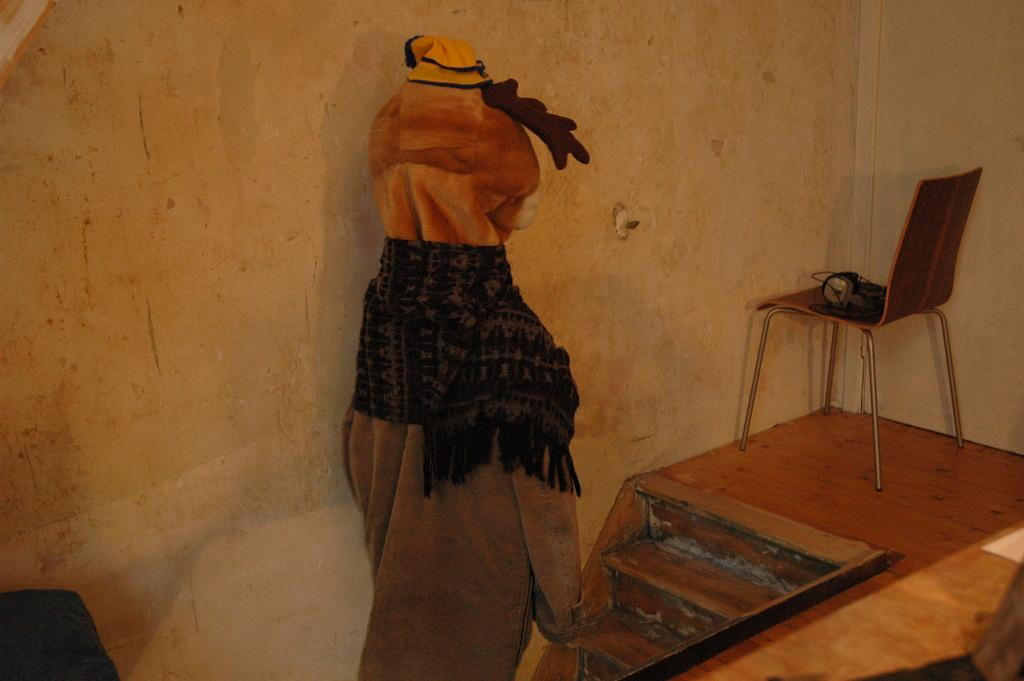What is hanging on the wall in the image? There is a dress hanging on the wall in the image. What can be seen near the dress on the wall? There are wooden stairs beside the dress. What piece of furniture is present in the image with headphones on it? There is a chair with headphones on it in the image. What type of sand can be seen on the chair with headphones in the image? There is no sand present in the image; the chair with headphones has no sand on it. 